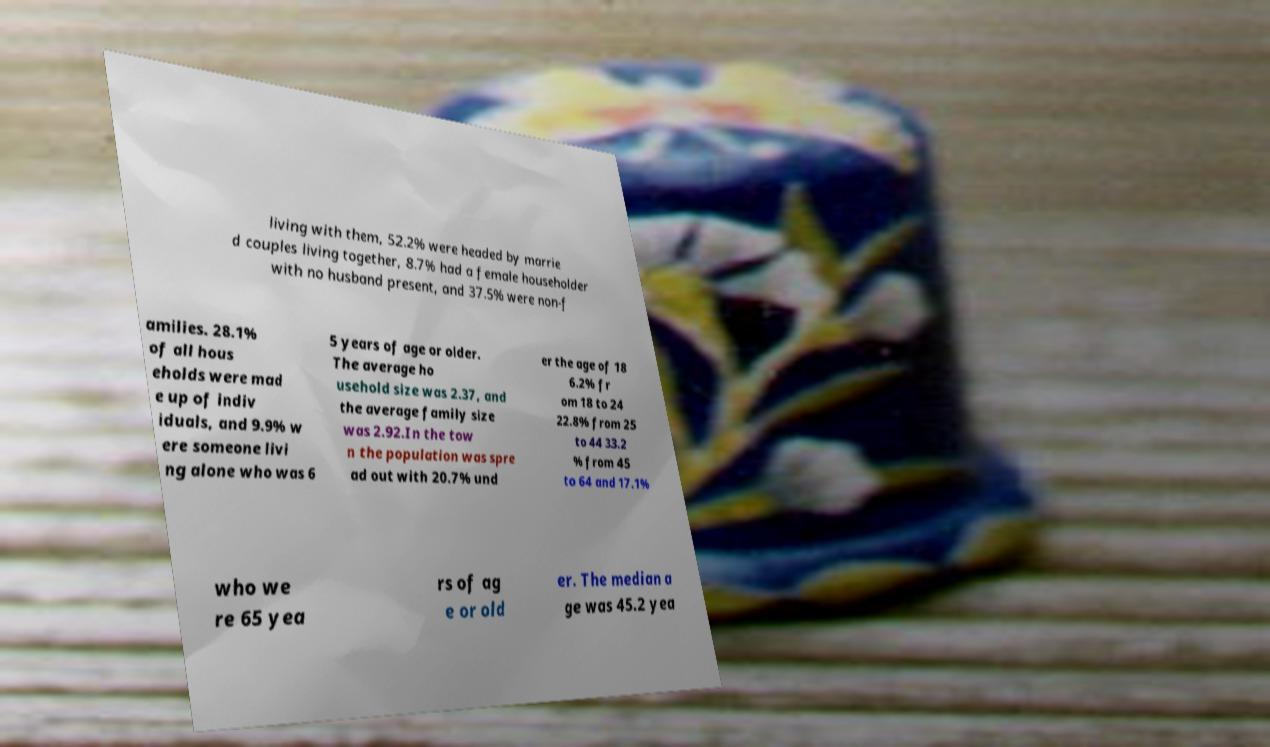Could you assist in decoding the text presented in this image and type it out clearly? living with them, 52.2% were headed by marrie d couples living together, 8.7% had a female householder with no husband present, and 37.5% were non-f amilies. 28.1% of all hous eholds were mad e up of indiv iduals, and 9.9% w ere someone livi ng alone who was 6 5 years of age or older. The average ho usehold size was 2.37, and the average family size was 2.92.In the tow n the population was spre ad out with 20.7% und er the age of 18 6.2% fr om 18 to 24 22.8% from 25 to 44 33.2 % from 45 to 64 and 17.1% who we re 65 yea rs of ag e or old er. The median a ge was 45.2 yea 